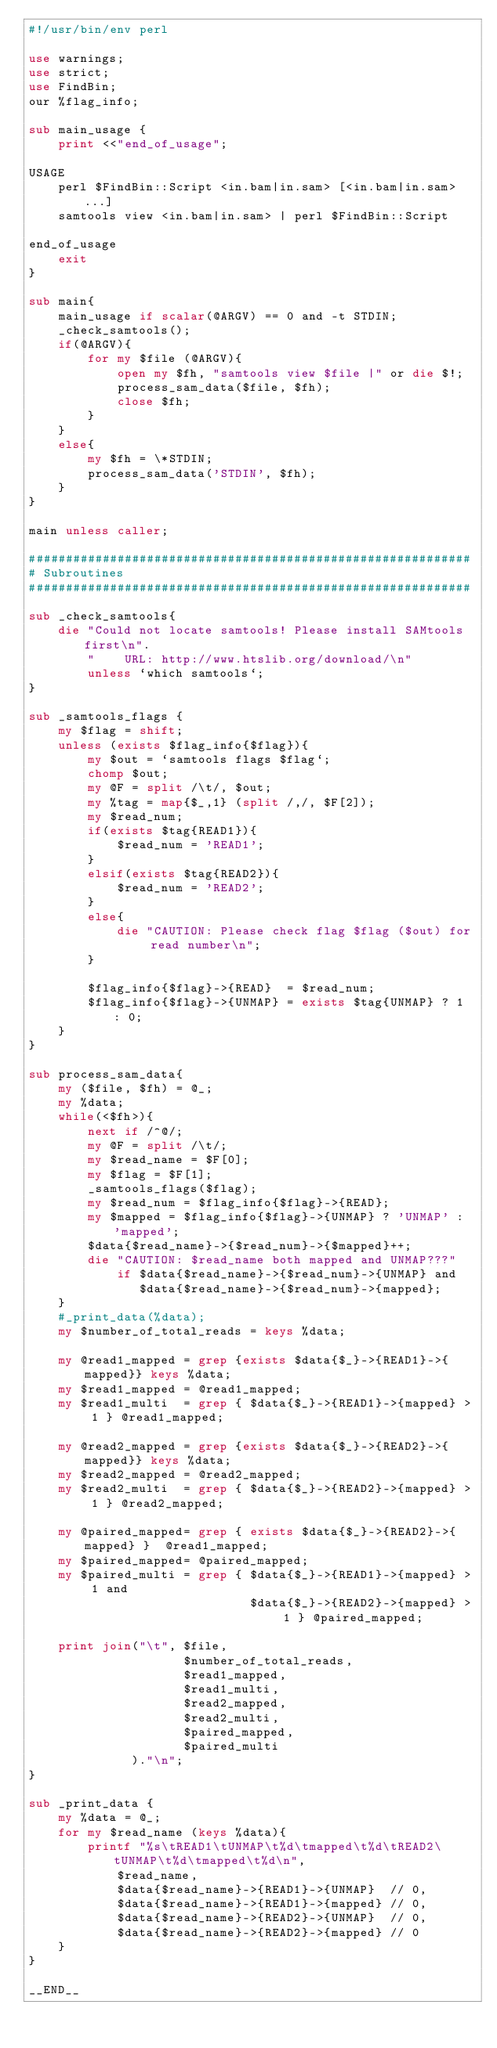<code> <loc_0><loc_0><loc_500><loc_500><_Perl_>#!/usr/bin/env perl

use warnings;
use strict;
use FindBin;
our %flag_info;

sub main_usage {
    print <<"end_of_usage";

USAGE
    perl $FindBin::Script <in.bam|in.sam> [<in.bam|in.sam> ...]
    samtools view <in.bam|in.sam> | perl $FindBin::Script

end_of_usage
    exit
}

sub main{
    main_usage if scalar(@ARGV) == 0 and -t STDIN;
    _check_samtools();
    if(@ARGV){
        for my $file (@ARGV){
            open my $fh, "samtools view $file |" or die $!;
            process_sam_data($file, $fh);
            close $fh;
        }
    }
    else{
        my $fh = \*STDIN;
        process_sam_data('STDIN', $fh);
    }
}

main unless caller;

############################################################
# Subroutines
############################################################

sub _check_samtools{
    die "Could not locate samtools! Please install SAMtools first\n".
        "    URL: http://www.htslib.org/download/\n"
        unless `which samtools`;
}

sub _samtools_flags {
    my $flag = shift;
    unless (exists $flag_info{$flag}){
        my $out = `samtools flags $flag`;
        chomp $out;
        my @F = split /\t/, $out;
        my %tag = map{$_,1} (split /,/, $F[2]);
        my $read_num;
        if(exists $tag{READ1}){
            $read_num = 'READ1';
        }
        elsif(exists $tag{READ2}){
            $read_num = 'READ2';
        }
        else{
            die "CAUTION: Please check flag $flag ($out) for read number\n";
        }

        $flag_info{$flag}->{READ}  = $read_num;
        $flag_info{$flag}->{UNMAP} = exists $tag{UNMAP} ? 1 : 0;
    }
}

sub process_sam_data{
    my ($file, $fh) = @_;
    my %data;
    while(<$fh>){
        next if /^@/;
        my @F = split /\t/;
        my $read_name = $F[0];
        my $flag = $F[1];
        _samtools_flags($flag);
        my $read_num = $flag_info{$flag}->{READ};
        my $mapped = $flag_info{$flag}->{UNMAP} ? 'UNMAP' : 'mapped';
        $data{$read_name}->{$read_num}->{$mapped}++;
        die "CAUTION: $read_name both mapped and UNMAP???"
            if $data{$read_name}->{$read_num}->{UNMAP} and 
               $data{$read_name}->{$read_num}->{mapped};
    }
    #_print_data(%data);
    my $number_of_total_reads = keys %data;

    my @read1_mapped = grep {exists $data{$_}->{READ1}->{mapped}} keys %data;
    my $read1_mapped = @read1_mapped;
    my $read1_multi  = grep { $data{$_}->{READ1}->{mapped} > 1 } @read1_mapped;

    my @read2_mapped = grep {exists $data{$_}->{READ2}->{mapped}} keys %data;
    my $read2_mapped = @read2_mapped;
    my $read2_multi  = grep { $data{$_}->{READ2}->{mapped} > 1 } @read2_mapped;

    my @paired_mapped= grep { exists $data{$_}->{READ2}->{mapped} }  @read1_mapped;
    my $paired_mapped= @paired_mapped;
    my $paired_multi = grep { $data{$_}->{READ1}->{mapped} > 1 and
                              $data{$_}->{READ2}->{mapped} > 1 } @paired_mapped;

    print join("\t", $file, 
                     $number_of_total_reads, 
                     $read1_mapped, 
                     $read1_multi, 
                     $read2_mapped,
                     $read2_multi, 
                     $paired_mapped,
                     $paired_multi
              )."\n";
}

sub _print_data {
    my %data = @_;
    for my $read_name (keys %data){
        printf "%s\tREAD1\tUNMAP\t%d\tmapped\t%d\tREAD2\tUNMAP\t%d\tmapped\t%d\n",
            $read_name, 
            $data{$read_name}->{READ1}->{UNMAP}  // 0,
            $data{$read_name}->{READ1}->{mapped} // 0,
            $data{$read_name}->{READ2}->{UNMAP}  // 0,
            $data{$read_name}->{READ2}->{mapped} // 0
    }
}

__END__

</code> 